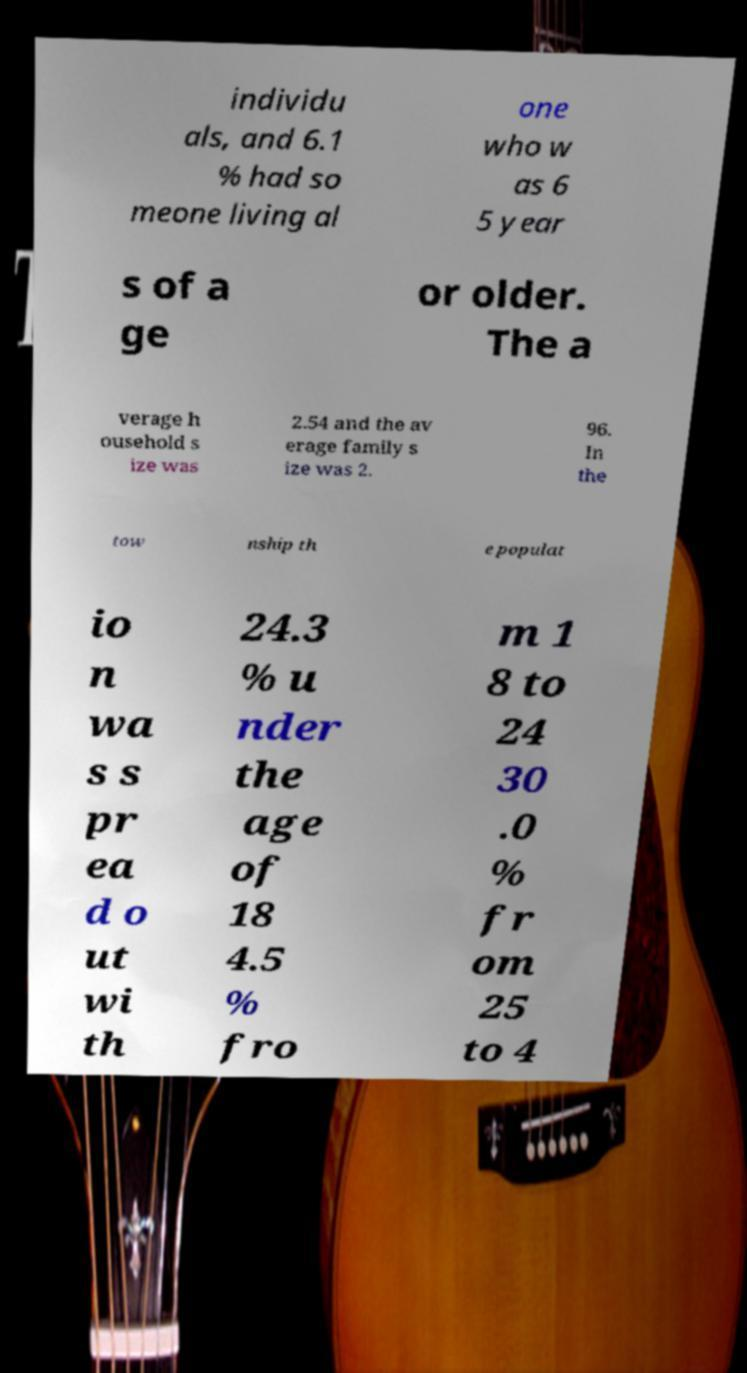What messages or text are displayed in this image? I need them in a readable, typed format. individu als, and 6.1 % had so meone living al one who w as 6 5 year s of a ge or older. The a verage h ousehold s ize was 2.54 and the av erage family s ize was 2. 96. In the tow nship th e populat io n wa s s pr ea d o ut wi th 24.3 % u nder the age of 18 4.5 % fro m 1 8 to 24 30 .0 % fr om 25 to 4 